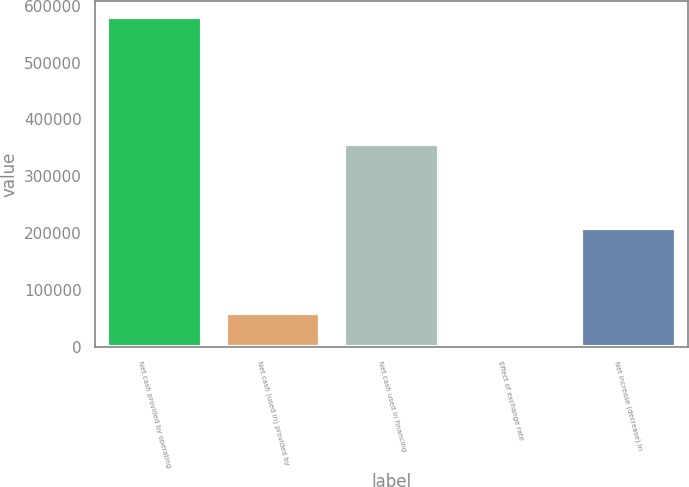<chart> <loc_0><loc_0><loc_500><loc_500><bar_chart><fcel>Net cash provided by operating<fcel>Net cash (used in) provided by<fcel>Net cash used in financing<fcel>Effect of exchange rate<fcel>Net increase (decrease) in<nl><fcel>579397<fcel>60203.2<fcel>357333<fcel>2515<fcel>208487<nl></chart> 